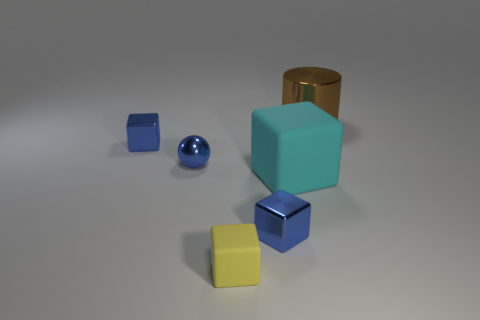Subtract all blue cylinders. Subtract all gray cubes. How many cylinders are left? 1 Add 3 cyan rubber cubes. How many objects exist? 9 Subtract all spheres. How many objects are left? 5 Subtract 0 yellow spheres. How many objects are left? 6 Subtract all metallic cylinders. Subtract all matte cubes. How many objects are left? 3 Add 5 small metal objects. How many small metal objects are left? 8 Add 3 shiny blocks. How many shiny blocks exist? 5 